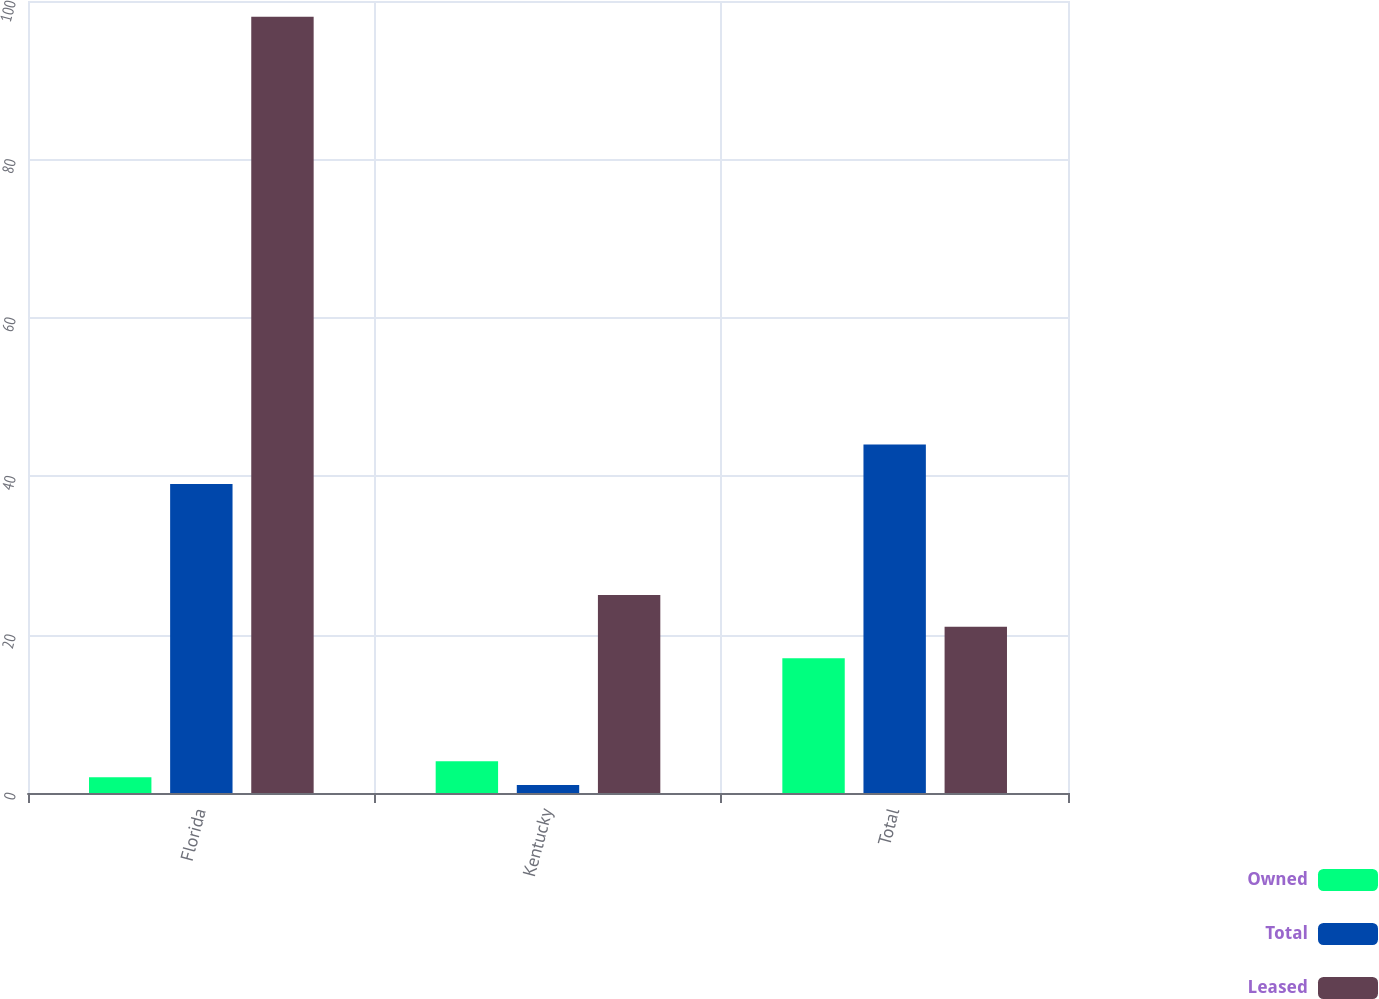Convert chart to OTSL. <chart><loc_0><loc_0><loc_500><loc_500><stacked_bar_chart><ecel><fcel>Florida<fcel>Kentucky<fcel>Total<nl><fcel>Owned<fcel>2<fcel>4<fcel>17<nl><fcel>Total<fcel>39<fcel>1<fcel>44<nl><fcel>Leased<fcel>98<fcel>25<fcel>21<nl></chart> 